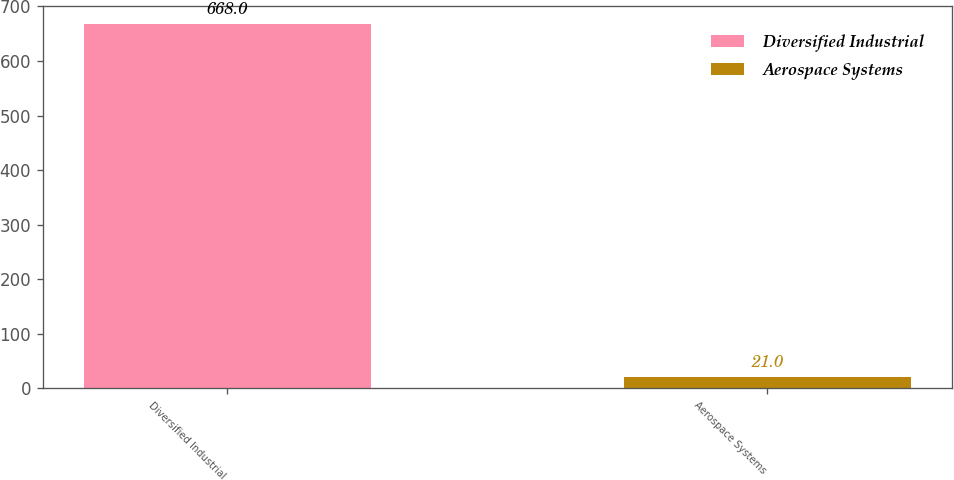Convert chart. <chart><loc_0><loc_0><loc_500><loc_500><bar_chart><fcel>Diversified Industrial<fcel>Aerospace Systems<nl><fcel>668<fcel>21<nl></chart> 